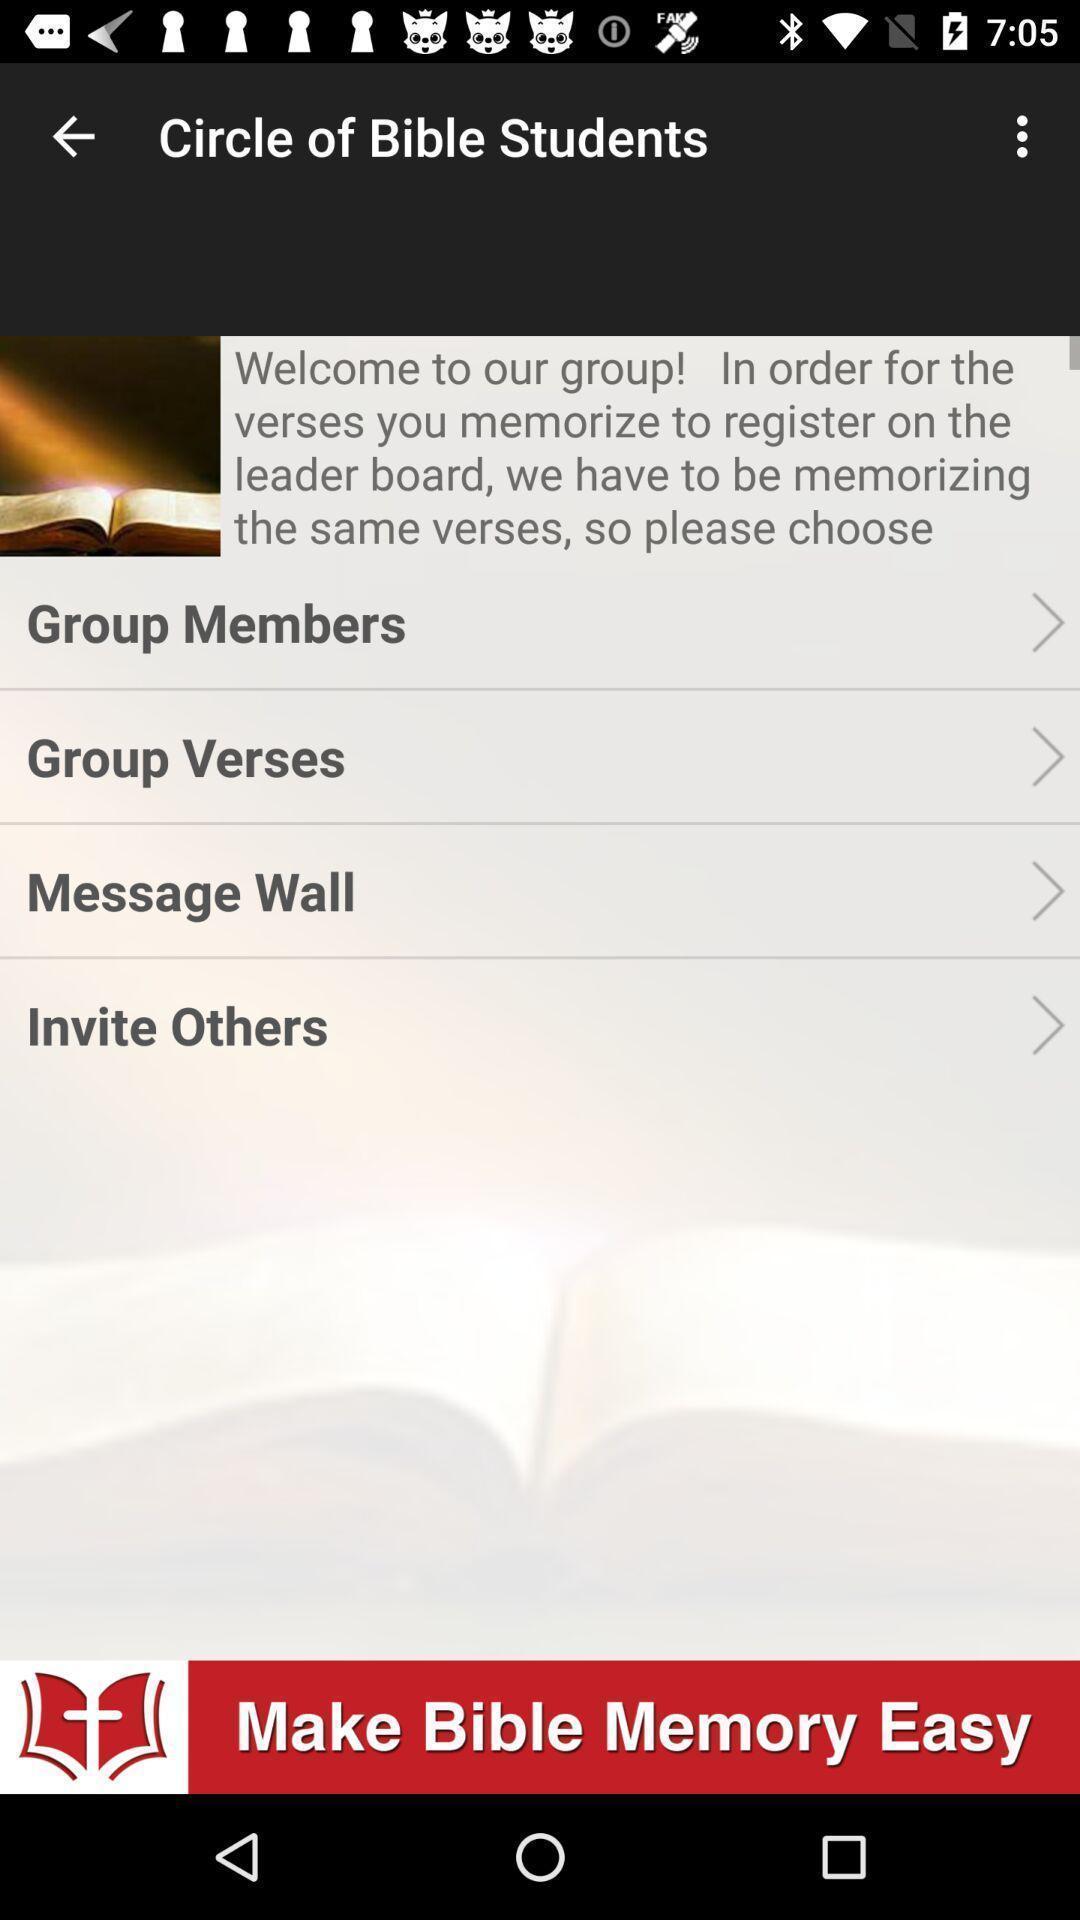What is the overall content of this screenshot? Screen shows multiple options. 